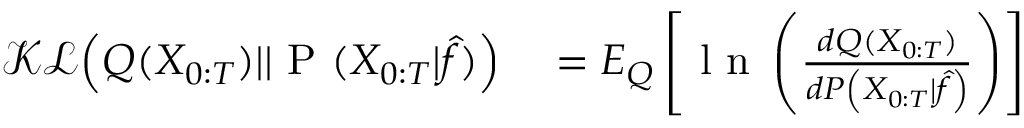<formula> <loc_0><loc_0><loc_500><loc_500>\begin{array} { r l } { \mathcal { K L } \left ( Q ( X _ { 0 \colon T } ) | | P ( X _ { 0 \colon T } | \hat { f } ) \right ) } & = E _ { Q } \left [ l n \left ( \frac { d { Q } ( X _ { 0 \colon T } ) } { d { P } \left ( X _ { 0 \colon T } | \hat { f } \right ) } \right ) \right ] } \end{array}</formula> 